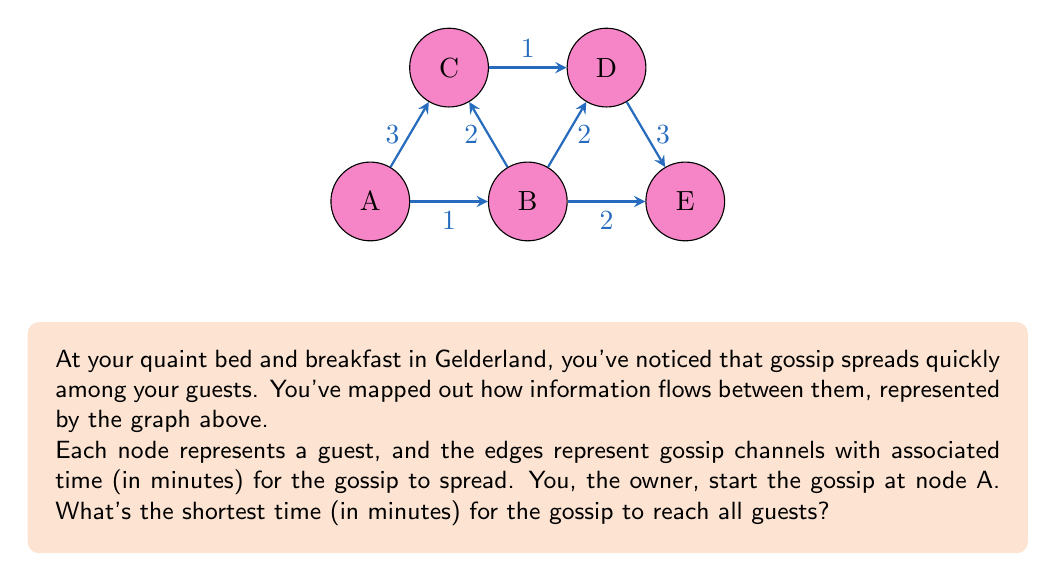What is the answer to this math problem? To solve this problem, we'll use Dijkstra's algorithm to find the shortest path from node A to all other nodes. This algorithm is ideal for finding the shortest paths in a weighted graph.

Step 1: Initialize distances
Set distance to A as 0, and all others as infinity.
A: 0, B: ∞, C: ∞, D: ∞, E: ∞

Step 2: Visit node A
Update neighbors of A:
B: min(∞, 0 + 1) = 1
C: min(∞, 0 + 3) = 3

Current state: A: 0, B: 1, C: 3, D: ∞, E: ∞

Step 3: Visit node B (closest unvisited)
Update neighbors of B:
C: min(3, 1 + 2) = 3
D: min(∞, 1 + 2) = 3
E: min(∞, 1 + 2) = 3

Current state: A: 0, B: 1, C: 3, D: 3, E: 3

Step 4: Visit node C
No updates needed (all paths through C are longer)

Step 5: Visit node D
Update neighbor E:
E: min(3, 3 + 3) = 3

Step 6: Visit node E
No updates needed

The final shortest distances from A are:
A: 0, B: 1, C: 3, D: 3, E: 3

The maximum of these values represents the time for gossip to reach all guests.

$$\text{Shortest time} = \max(0, 1, 3, 3, 3) = 3\text{ minutes}$$
Answer: 3 minutes 